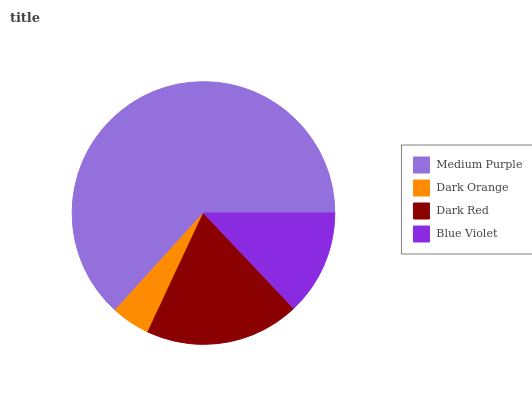Is Dark Orange the minimum?
Answer yes or no. Yes. Is Medium Purple the maximum?
Answer yes or no. Yes. Is Dark Red the minimum?
Answer yes or no. No. Is Dark Red the maximum?
Answer yes or no. No. Is Dark Red greater than Dark Orange?
Answer yes or no. Yes. Is Dark Orange less than Dark Red?
Answer yes or no. Yes. Is Dark Orange greater than Dark Red?
Answer yes or no. No. Is Dark Red less than Dark Orange?
Answer yes or no. No. Is Dark Red the high median?
Answer yes or no. Yes. Is Blue Violet the low median?
Answer yes or no. Yes. Is Blue Violet the high median?
Answer yes or no. No. Is Medium Purple the low median?
Answer yes or no. No. 